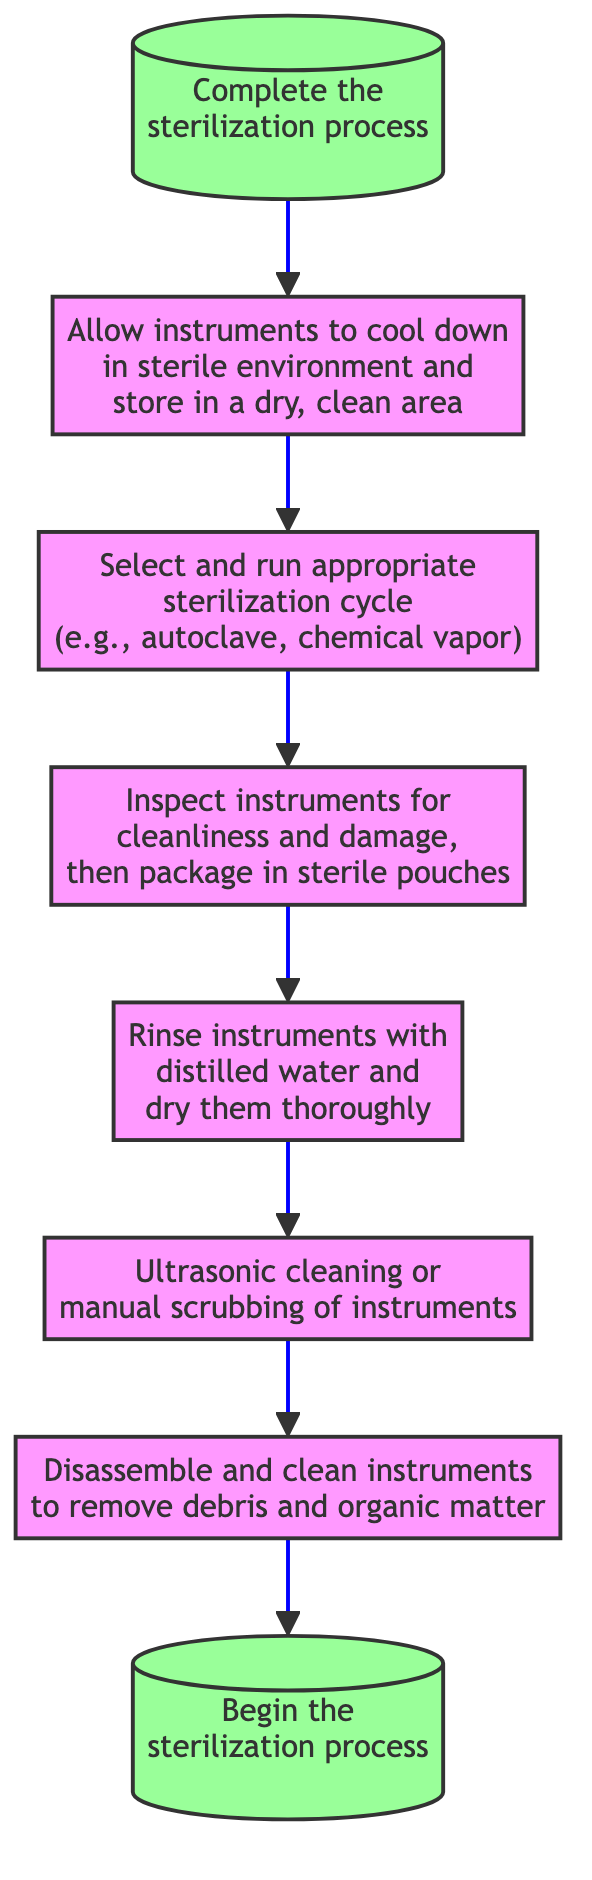What is the first step in the sterilization process? The first step is indicated by the "Start" node, which states "Begin the sterilization process."
Answer: Begin the sterilization process What follows "Device Preparation"? After "Device Preparation," the next step is "Pre-Sterilization Cleaning," as outlined in the flowchart.
Answer: Pre-Sterilization Cleaning How many total steps are there in the sterilization process? Counting each node in the flowchart from "Start" to "End," there are seven steps in total.
Answer: Seven What is the last action taken before "End"? The last action before reaching "End" is "Cooling and Storage," which allows instruments to cool and be stored in a clean area.
Answer: Cooling and Storage Is "Rinse and Dry" executed before or after "Inspection and Packaging"? "Rinse and Dry" is executed before "Inspection and Packaging," as shown in the flow of the diagram.
Answer: Before Between which two steps does "Sterilization Cycle" occur? "Sterilization Cycle" occurs between "Inspection and Packaging" and "Cooling and Storage," marking the transition in the process flow.
Answer: Inspection and Packaging, Cooling and Storage What is the description associated with "Cooling and Storage"? The description associated with "Cooling and Storage" is "Allow instruments to cool down in sterile environment and store in a dry, clean area."
Answer: Allow instruments to cool down in sterile environment and store in a dry, clean area Which step involves checking for damage to instruments? The step that involves inspecting instruments for cleanliness and damage is "Inspection and Packaging."
Answer: Inspection and Packaging What comes immediately before "Rinse and Dry" in the flowchart? Immediately preceding "Rinse and Dry" is "Pre-Sterilization Cleaning," which involves ultrasonic cleaning or manual scrubbing.
Answer: Pre-Sterilization Cleaning 